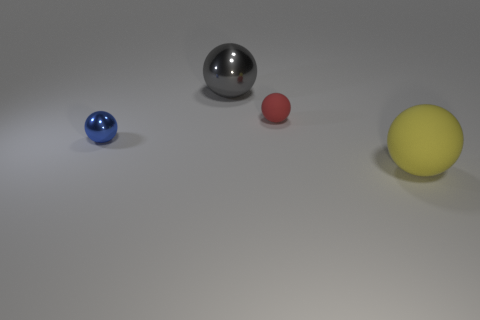There is a large metal ball; is it the same color as the small sphere that is behind the blue metal object?
Keep it short and to the point. No. Is the small metallic sphere the same color as the large shiny thing?
Your answer should be compact. No. What number of other things are the same color as the large rubber thing?
Make the answer very short. 0. Is the number of spheres right of the yellow thing less than the number of large shiny things?
Give a very brief answer. Yes. Do the big object that is behind the blue ball and the yellow ball have the same material?
Make the answer very short. No. What is the shape of the metal thing to the left of the large sphere that is behind the matte thing to the left of the large yellow rubber thing?
Give a very brief answer. Sphere. Are there any rubber blocks of the same size as the red rubber sphere?
Give a very brief answer. No. The red thing is what size?
Give a very brief answer. Small. How many purple rubber cubes are the same size as the red sphere?
Your answer should be compact. 0. Is the number of yellow objects that are behind the small red object less than the number of rubber things on the left side of the tiny blue metal object?
Your answer should be very brief. No. 